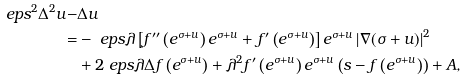<formula> <loc_0><loc_0><loc_500><loc_500>\ e p s ^ { 2 } \Delta ^ { 2 } u - & \Delta u \\ = & - \ e p s \lambda \left [ f ^ { \prime \prime } \left ( e ^ { \sigma + u } \right ) e ^ { \sigma + u } + f ^ { \prime } \left ( e ^ { \sigma + u } \right ) \right ] e ^ { \sigma + u } \left | \nabla ( \sigma + u ) \right | ^ { 2 } \\ & + 2 \ e p s \lambda \Delta f \left ( e ^ { \sigma + u } \right ) + \lambda ^ { 2 } f ^ { \prime } \left ( e ^ { \sigma + u } \right ) e ^ { \sigma + u } \left ( s - f \left ( e ^ { \sigma + u } \right ) \right ) + A ,</formula> 